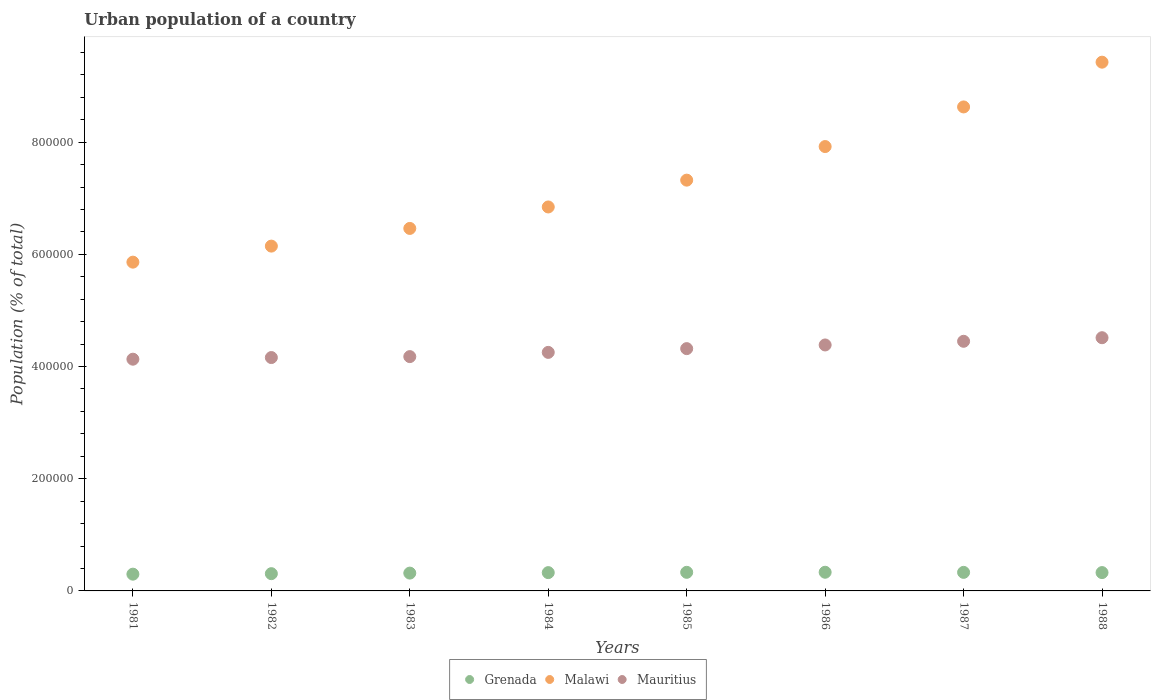How many different coloured dotlines are there?
Your answer should be very brief. 3. Is the number of dotlines equal to the number of legend labels?
Give a very brief answer. Yes. What is the urban population in Malawi in 1985?
Your response must be concise. 7.32e+05. Across all years, what is the maximum urban population in Malawi?
Offer a very short reply. 9.43e+05. Across all years, what is the minimum urban population in Mauritius?
Offer a terse response. 4.13e+05. In which year was the urban population in Malawi maximum?
Provide a succinct answer. 1988. What is the total urban population in Malawi in the graph?
Your answer should be very brief. 5.86e+06. What is the difference between the urban population in Malawi in 1984 and that in 1985?
Your answer should be very brief. -4.78e+04. What is the difference between the urban population in Mauritius in 1985 and the urban population in Malawi in 1982?
Make the answer very short. -1.83e+05. What is the average urban population in Mauritius per year?
Make the answer very short. 4.30e+05. In the year 1984, what is the difference between the urban population in Mauritius and urban population in Grenada?
Offer a very short reply. 3.93e+05. What is the ratio of the urban population in Grenada in 1982 to that in 1988?
Your answer should be very brief. 0.94. Is the difference between the urban population in Mauritius in 1986 and 1987 greater than the difference between the urban population in Grenada in 1986 and 1987?
Make the answer very short. No. What is the difference between the highest and the second highest urban population in Malawi?
Provide a succinct answer. 7.98e+04. What is the difference between the highest and the lowest urban population in Mauritius?
Give a very brief answer. 3.83e+04. Does the urban population in Grenada monotonically increase over the years?
Give a very brief answer. No. Is the urban population in Mauritius strictly less than the urban population in Grenada over the years?
Your response must be concise. No. How many dotlines are there?
Give a very brief answer. 3. How many years are there in the graph?
Provide a succinct answer. 8. What is the difference between two consecutive major ticks on the Y-axis?
Offer a terse response. 2.00e+05. Are the values on the major ticks of Y-axis written in scientific E-notation?
Provide a short and direct response. No. Does the graph contain any zero values?
Make the answer very short. No. Does the graph contain grids?
Your answer should be very brief. No. What is the title of the graph?
Your answer should be compact. Urban population of a country. What is the label or title of the Y-axis?
Your answer should be very brief. Population (% of total). What is the Population (% of total) in Grenada in 1981?
Provide a succinct answer. 2.99e+04. What is the Population (% of total) in Malawi in 1981?
Ensure brevity in your answer.  5.86e+05. What is the Population (% of total) of Mauritius in 1981?
Ensure brevity in your answer.  4.13e+05. What is the Population (% of total) of Grenada in 1982?
Your answer should be very brief. 3.08e+04. What is the Population (% of total) in Malawi in 1982?
Ensure brevity in your answer.  6.15e+05. What is the Population (% of total) in Mauritius in 1982?
Ensure brevity in your answer.  4.16e+05. What is the Population (% of total) in Grenada in 1983?
Provide a succinct answer. 3.18e+04. What is the Population (% of total) in Malawi in 1983?
Offer a terse response. 6.46e+05. What is the Population (% of total) of Mauritius in 1983?
Give a very brief answer. 4.18e+05. What is the Population (% of total) of Grenada in 1984?
Provide a short and direct response. 3.26e+04. What is the Population (% of total) of Malawi in 1984?
Your answer should be very brief. 6.84e+05. What is the Population (% of total) in Mauritius in 1984?
Give a very brief answer. 4.25e+05. What is the Population (% of total) in Grenada in 1985?
Your answer should be compact. 3.32e+04. What is the Population (% of total) in Malawi in 1985?
Your answer should be compact. 7.32e+05. What is the Population (% of total) of Mauritius in 1985?
Your answer should be compact. 4.32e+05. What is the Population (% of total) in Grenada in 1986?
Keep it short and to the point. 3.33e+04. What is the Population (% of total) in Malawi in 1986?
Offer a terse response. 7.92e+05. What is the Population (% of total) of Mauritius in 1986?
Give a very brief answer. 4.38e+05. What is the Population (% of total) of Grenada in 1987?
Make the answer very short. 3.31e+04. What is the Population (% of total) of Malawi in 1987?
Your answer should be compact. 8.63e+05. What is the Population (% of total) in Mauritius in 1987?
Offer a very short reply. 4.45e+05. What is the Population (% of total) of Grenada in 1988?
Offer a terse response. 3.27e+04. What is the Population (% of total) of Malawi in 1988?
Offer a terse response. 9.43e+05. What is the Population (% of total) in Mauritius in 1988?
Provide a succinct answer. 4.51e+05. Across all years, what is the maximum Population (% of total) of Grenada?
Ensure brevity in your answer.  3.33e+04. Across all years, what is the maximum Population (% of total) in Malawi?
Ensure brevity in your answer.  9.43e+05. Across all years, what is the maximum Population (% of total) in Mauritius?
Provide a succinct answer. 4.51e+05. Across all years, what is the minimum Population (% of total) in Grenada?
Ensure brevity in your answer.  2.99e+04. Across all years, what is the minimum Population (% of total) in Malawi?
Your answer should be very brief. 5.86e+05. Across all years, what is the minimum Population (% of total) of Mauritius?
Give a very brief answer. 4.13e+05. What is the total Population (% of total) of Grenada in the graph?
Offer a very short reply. 2.57e+05. What is the total Population (% of total) in Malawi in the graph?
Provide a short and direct response. 5.86e+06. What is the total Population (% of total) of Mauritius in the graph?
Give a very brief answer. 3.44e+06. What is the difference between the Population (% of total) in Grenada in 1981 and that in 1982?
Provide a succinct answer. -875. What is the difference between the Population (% of total) of Malawi in 1981 and that in 1982?
Keep it short and to the point. -2.86e+04. What is the difference between the Population (% of total) in Mauritius in 1981 and that in 1982?
Make the answer very short. -2927. What is the difference between the Population (% of total) in Grenada in 1981 and that in 1983?
Keep it short and to the point. -1877. What is the difference between the Population (% of total) in Malawi in 1981 and that in 1983?
Provide a succinct answer. -6.01e+04. What is the difference between the Population (% of total) in Mauritius in 1981 and that in 1983?
Your answer should be compact. -4607. What is the difference between the Population (% of total) in Grenada in 1981 and that in 1984?
Keep it short and to the point. -2739. What is the difference between the Population (% of total) of Malawi in 1981 and that in 1984?
Ensure brevity in your answer.  -9.84e+04. What is the difference between the Population (% of total) in Mauritius in 1981 and that in 1984?
Give a very brief answer. -1.21e+04. What is the difference between the Population (% of total) of Grenada in 1981 and that in 1985?
Give a very brief answer. -3273. What is the difference between the Population (% of total) of Malawi in 1981 and that in 1985?
Offer a terse response. -1.46e+05. What is the difference between the Population (% of total) in Mauritius in 1981 and that in 1985?
Provide a succinct answer. -1.88e+04. What is the difference between the Population (% of total) in Grenada in 1981 and that in 1986?
Ensure brevity in your answer.  -3402. What is the difference between the Population (% of total) of Malawi in 1981 and that in 1986?
Provide a succinct answer. -2.06e+05. What is the difference between the Population (% of total) in Mauritius in 1981 and that in 1986?
Keep it short and to the point. -2.54e+04. What is the difference between the Population (% of total) in Grenada in 1981 and that in 1987?
Ensure brevity in your answer.  -3196. What is the difference between the Population (% of total) of Malawi in 1981 and that in 1987?
Your answer should be very brief. -2.77e+05. What is the difference between the Population (% of total) in Mauritius in 1981 and that in 1987?
Provide a short and direct response. -3.19e+04. What is the difference between the Population (% of total) of Grenada in 1981 and that in 1988?
Make the answer very short. -2805. What is the difference between the Population (% of total) of Malawi in 1981 and that in 1988?
Make the answer very short. -3.57e+05. What is the difference between the Population (% of total) of Mauritius in 1981 and that in 1988?
Provide a short and direct response. -3.83e+04. What is the difference between the Population (% of total) in Grenada in 1982 and that in 1983?
Give a very brief answer. -1002. What is the difference between the Population (% of total) in Malawi in 1982 and that in 1983?
Your answer should be very brief. -3.15e+04. What is the difference between the Population (% of total) of Mauritius in 1982 and that in 1983?
Give a very brief answer. -1680. What is the difference between the Population (% of total) in Grenada in 1982 and that in 1984?
Give a very brief answer. -1864. What is the difference between the Population (% of total) in Malawi in 1982 and that in 1984?
Offer a terse response. -6.98e+04. What is the difference between the Population (% of total) of Mauritius in 1982 and that in 1984?
Make the answer very short. -9219. What is the difference between the Population (% of total) of Grenada in 1982 and that in 1985?
Offer a very short reply. -2398. What is the difference between the Population (% of total) in Malawi in 1982 and that in 1985?
Ensure brevity in your answer.  -1.18e+05. What is the difference between the Population (% of total) in Mauritius in 1982 and that in 1985?
Provide a short and direct response. -1.59e+04. What is the difference between the Population (% of total) in Grenada in 1982 and that in 1986?
Make the answer very short. -2527. What is the difference between the Population (% of total) in Malawi in 1982 and that in 1986?
Your answer should be compact. -1.77e+05. What is the difference between the Population (% of total) of Mauritius in 1982 and that in 1986?
Make the answer very short. -2.24e+04. What is the difference between the Population (% of total) of Grenada in 1982 and that in 1987?
Your answer should be very brief. -2321. What is the difference between the Population (% of total) of Malawi in 1982 and that in 1987?
Offer a very short reply. -2.48e+05. What is the difference between the Population (% of total) of Mauritius in 1982 and that in 1987?
Give a very brief answer. -2.90e+04. What is the difference between the Population (% of total) of Grenada in 1982 and that in 1988?
Give a very brief answer. -1930. What is the difference between the Population (% of total) of Malawi in 1982 and that in 1988?
Keep it short and to the point. -3.28e+05. What is the difference between the Population (% of total) of Mauritius in 1982 and that in 1988?
Make the answer very short. -3.54e+04. What is the difference between the Population (% of total) in Grenada in 1983 and that in 1984?
Ensure brevity in your answer.  -862. What is the difference between the Population (% of total) in Malawi in 1983 and that in 1984?
Your answer should be compact. -3.83e+04. What is the difference between the Population (% of total) of Mauritius in 1983 and that in 1984?
Give a very brief answer. -7539. What is the difference between the Population (% of total) in Grenada in 1983 and that in 1985?
Your answer should be very brief. -1396. What is the difference between the Population (% of total) in Malawi in 1983 and that in 1985?
Make the answer very short. -8.61e+04. What is the difference between the Population (% of total) in Mauritius in 1983 and that in 1985?
Offer a terse response. -1.42e+04. What is the difference between the Population (% of total) in Grenada in 1983 and that in 1986?
Offer a terse response. -1525. What is the difference between the Population (% of total) of Malawi in 1983 and that in 1986?
Ensure brevity in your answer.  -1.46e+05. What is the difference between the Population (% of total) in Mauritius in 1983 and that in 1986?
Keep it short and to the point. -2.08e+04. What is the difference between the Population (% of total) of Grenada in 1983 and that in 1987?
Give a very brief answer. -1319. What is the difference between the Population (% of total) in Malawi in 1983 and that in 1987?
Your response must be concise. -2.17e+05. What is the difference between the Population (% of total) of Mauritius in 1983 and that in 1987?
Make the answer very short. -2.73e+04. What is the difference between the Population (% of total) in Grenada in 1983 and that in 1988?
Your answer should be compact. -928. What is the difference between the Population (% of total) in Malawi in 1983 and that in 1988?
Provide a short and direct response. -2.96e+05. What is the difference between the Population (% of total) of Mauritius in 1983 and that in 1988?
Your answer should be compact. -3.37e+04. What is the difference between the Population (% of total) of Grenada in 1984 and that in 1985?
Make the answer very short. -534. What is the difference between the Population (% of total) in Malawi in 1984 and that in 1985?
Your response must be concise. -4.78e+04. What is the difference between the Population (% of total) in Mauritius in 1984 and that in 1985?
Your answer should be compact. -6684. What is the difference between the Population (% of total) of Grenada in 1984 and that in 1986?
Ensure brevity in your answer.  -663. What is the difference between the Population (% of total) in Malawi in 1984 and that in 1986?
Keep it short and to the point. -1.08e+05. What is the difference between the Population (% of total) of Mauritius in 1984 and that in 1986?
Keep it short and to the point. -1.32e+04. What is the difference between the Population (% of total) in Grenada in 1984 and that in 1987?
Provide a succinct answer. -457. What is the difference between the Population (% of total) of Malawi in 1984 and that in 1987?
Make the answer very short. -1.78e+05. What is the difference between the Population (% of total) of Mauritius in 1984 and that in 1987?
Your answer should be compact. -1.98e+04. What is the difference between the Population (% of total) in Grenada in 1984 and that in 1988?
Provide a succinct answer. -66. What is the difference between the Population (% of total) of Malawi in 1984 and that in 1988?
Provide a short and direct response. -2.58e+05. What is the difference between the Population (% of total) of Mauritius in 1984 and that in 1988?
Offer a very short reply. -2.61e+04. What is the difference between the Population (% of total) in Grenada in 1985 and that in 1986?
Make the answer very short. -129. What is the difference between the Population (% of total) in Malawi in 1985 and that in 1986?
Keep it short and to the point. -5.99e+04. What is the difference between the Population (% of total) of Mauritius in 1985 and that in 1986?
Your response must be concise. -6544. What is the difference between the Population (% of total) in Malawi in 1985 and that in 1987?
Keep it short and to the point. -1.31e+05. What is the difference between the Population (% of total) of Mauritius in 1985 and that in 1987?
Ensure brevity in your answer.  -1.31e+04. What is the difference between the Population (% of total) in Grenada in 1985 and that in 1988?
Provide a short and direct response. 468. What is the difference between the Population (% of total) in Malawi in 1985 and that in 1988?
Make the answer very short. -2.10e+05. What is the difference between the Population (% of total) in Mauritius in 1985 and that in 1988?
Offer a terse response. -1.95e+04. What is the difference between the Population (% of total) in Grenada in 1986 and that in 1987?
Give a very brief answer. 206. What is the difference between the Population (% of total) in Malawi in 1986 and that in 1987?
Make the answer very short. -7.06e+04. What is the difference between the Population (% of total) in Mauritius in 1986 and that in 1987?
Provide a succinct answer. -6546. What is the difference between the Population (% of total) in Grenada in 1986 and that in 1988?
Make the answer very short. 597. What is the difference between the Population (% of total) of Malawi in 1986 and that in 1988?
Your response must be concise. -1.50e+05. What is the difference between the Population (% of total) of Mauritius in 1986 and that in 1988?
Offer a very short reply. -1.29e+04. What is the difference between the Population (% of total) in Grenada in 1987 and that in 1988?
Your response must be concise. 391. What is the difference between the Population (% of total) in Malawi in 1987 and that in 1988?
Offer a very short reply. -7.98e+04. What is the difference between the Population (% of total) in Mauritius in 1987 and that in 1988?
Provide a succinct answer. -6371. What is the difference between the Population (% of total) of Grenada in 1981 and the Population (% of total) of Malawi in 1982?
Provide a short and direct response. -5.85e+05. What is the difference between the Population (% of total) of Grenada in 1981 and the Population (% of total) of Mauritius in 1982?
Provide a succinct answer. -3.86e+05. What is the difference between the Population (% of total) of Malawi in 1981 and the Population (% of total) of Mauritius in 1982?
Give a very brief answer. 1.70e+05. What is the difference between the Population (% of total) of Grenada in 1981 and the Population (% of total) of Malawi in 1983?
Provide a succinct answer. -6.16e+05. What is the difference between the Population (% of total) in Grenada in 1981 and the Population (% of total) in Mauritius in 1983?
Provide a succinct answer. -3.88e+05. What is the difference between the Population (% of total) of Malawi in 1981 and the Population (% of total) of Mauritius in 1983?
Give a very brief answer. 1.68e+05. What is the difference between the Population (% of total) of Grenada in 1981 and the Population (% of total) of Malawi in 1984?
Offer a terse response. -6.55e+05. What is the difference between the Population (% of total) of Grenada in 1981 and the Population (% of total) of Mauritius in 1984?
Make the answer very short. -3.95e+05. What is the difference between the Population (% of total) of Malawi in 1981 and the Population (% of total) of Mauritius in 1984?
Ensure brevity in your answer.  1.61e+05. What is the difference between the Population (% of total) in Grenada in 1981 and the Population (% of total) in Malawi in 1985?
Provide a succinct answer. -7.02e+05. What is the difference between the Population (% of total) in Grenada in 1981 and the Population (% of total) in Mauritius in 1985?
Provide a short and direct response. -4.02e+05. What is the difference between the Population (% of total) of Malawi in 1981 and the Population (% of total) of Mauritius in 1985?
Provide a short and direct response. 1.54e+05. What is the difference between the Population (% of total) in Grenada in 1981 and the Population (% of total) in Malawi in 1986?
Your response must be concise. -7.62e+05. What is the difference between the Population (% of total) in Grenada in 1981 and the Population (% of total) in Mauritius in 1986?
Ensure brevity in your answer.  -4.09e+05. What is the difference between the Population (% of total) of Malawi in 1981 and the Population (% of total) of Mauritius in 1986?
Your response must be concise. 1.48e+05. What is the difference between the Population (% of total) of Grenada in 1981 and the Population (% of total) of Malawi in 1987?
Give a very brief answer. -8.33e+05. What is the difference between the Population (% of total) of Grenada in 1981 and the Population (% of total) of Mauritius in 1987?
Provide a succinct answer. -4.15e+05. What is the difference between the Population (% of total) of Malawi in 1981 and the Population (% of total) of Mauritius in 1987?
Your response must be concise. 1.41e+05. What is the difference between the Population (% of total) of Grenada in 1981 and the Population (% of total) of Malawi in 1988?
Keep it short and to the point. -9.13e+05. What is the difference between the Population (% of total) of Grenada in 1981 and the Population (% of total) of Mauritius in 1988?
Give a very brief answer. -4.22e+05. What is the difference between the Population (% of total) of Malawi in 1981 and the Population (% of total) of Mauritius in 1988?
Your response must be concise. 1.35e+05. What is the difference between the Population (% of total) in Grenada in 1982 and the Population (% of total) in Malawi in 1983?
Your answer should be very brief. -6.15e+05. What is the difference between the Population (% of total) in Grenada in 1982 and the Population (% of total) in Mauritius in 1983?
Your answer should be compact. -3.87e+05. What is the difference between the Population (% of total) of Malawi in 1982 and the Population (% of total) of Mauritius in 1983?
Your answer should be compact. 1.97e+05. What is the difference between the Population (% of total) of Grenada in 1982 and the Population (% of total) of Malawi in 1984?
Ensure brevity in your answer.  -6.54e+05. What is the difference between the Population (% of total) of Grenada in 1982 and the Population (% of total) of Mauritius in 1984?
Offer a very short reply. -3.94e+05. What is the difference between the Population (% of total) in Malawi in 1982 and the Population (% of total) in Mauritius in 1984?
Keep it short and to the point. 1.89e+05. What is the difference between the Population (% of total) in Grenada in 1982 and the Population (% of total) in Malawi in 1985?
Provide a short and direct response. -7.02e+05. What is the difference between the Population (% of total) in Grenada in 1982 and the Population (% of total) in Mauritius in 1985?
Make the answer very short. -4.01e+05. What is the difference between the Population (% of total) in Malawi in 1982 and the Population (% of total) in Mauritius in 1985?
Offer a very short reply. 1.83e+05. What is the difference between the Population (% of total) of Grenada in 1982 and the Population (% of total) of Malawi in 1986?
Your response must be concise. -7.61e+05. What is the difference between the Population (% of total) of Grenada in 1982 and the Population (% of total) of Mauritius in 1986?
Your answer should be very brief. -4.08e+05. What is the difference between the Population (% of total) of Malawi in 1982 and the Population (% of total) of Mauritius in 1986?
Make the answer very short. 1.76e+05. What is the difference between the Population (% of total) in Grenada in 1982 and the Population (% of total) in Malawi in 1987?
Ensure brevity in your answer.  -8.32e+05. What is the difference between the Population (% of total) in Grenada in 1982 and the Population (% of total) in Mauritius in 1987?
Offer a very short reply. -4.14e+05. What is the difference between the Population (% of total) of Malawi in 1982 and the Population (% of total) of Mauritius in 1987?
Provide a succinct answer. 1.70e+05. What is the difference between the Population (% of total) in Grenada in 1982 and the Population (% of total) in Malawi in 1988?
Make the answer very short. -9.12e+05. What is the difference between the Population (% of total) of Grenada in 1982 and the Population (% of total) of Mauritius in 1988?
Make the answer very short. -4.21e+05. What is the difference between the Population (% of total) of Malawi in 1982 and the Population (% of total) of Mauritius in 1988?
Offer a very short reply. 1.63e+05. What is the difference between the Population (% of total) of Grenada in 1983 and the Population (% of total) of Malawi in 1984?
Your answer should be very brief. -6.53e+05. What is the difference between the Population (% of total) of Grenada in 1983 and the Population (% of total) of Mauritius in 1984?
Your answer should be very brief. -3.93e+05. What is the difference between the Population (% of total) in Malawi in 1983 and the Population (% of total) in Mauritius in 1984?
Make the answer very short. 2.21e+05. What is the difference between the Population (% of total) in Grenada in 1983 and the Population (% of total) in Malawi in 1985?
Ensure brevity in your answer.  -7.01e+05. What is the difference between the Population (% of total) in Grenada in 1983 and the Population (% of total) in Mauritius in 1985?
Keep it short and to the point. -4.00e+05. What is the difference between the Population (% of total) of Malawi in 1983 and the Population (% of total) of Mauritius in 1985?
Your response must be concise. 2.14e+05. What is the difference between the Population (% of total) in Grenada in 1983 and the Population (% of total) in Malawi in 1986?
Make the answer very short. -7.60e+05. What is the difference between the Population (% of total) in Grenada in 1983 and the Population (% of total) in Mauritius in 1986?
Keep it short and to the point. -4.07e+05. What is the difference between the Population (% of total) of Malawi in 1983 and the Population (% of total) of Mauritius in 1986?
Your response must be concise. 2.08e+05. What is the difference between the Population (% of total) of Grenada in 1983 and the Population (% of total) of Malawi in 1987?
Give a very brief answer. -8.31e+05. What is the difference between the Population (% of total) in Grenada in 1983 and the Population (% of total) in Mauritius in 1987?
Offer a very short reply. -4.13e+05. What is the difference between the Population (% of total) of Malawi in 1983 and the Population (% of total) of Mauritius in 1987?
Make the answer very short. 2.01e+05. What is the difference between the Population (% of total) of Grenada in 1983 and the Population (% of total) of Malawi in 1988?
Your answer should be compact. -9.11e+05. What is the difference between the Population (% of total) of Grenada in 1983 and the Population (% of total) of Mauritius in 1988?
Give a very brief answer. -4.20e+05. What is the difference between the Population (% of total) in Malawi in 1983 and the Population (% of total) in Mauritius in 1988?
Make the answer very short. 1.95e+05. What is the difference between the Population (% of total) of Grenada in 1984 and the Population (% of total) of Malawi in 1985?
Keep it short and to the point. -7.00e+05. What is the difference between the Population (% of total) of Grenada in 1984 and the Population (% of total) of Mauritius in 1985?
Offer a terse response. -3.99e+05. What is the difference between the Population (% of total) in Malawi in 1984 and the Population (% of total) in Mauritius in 1985?
Your answer should be very brief. 2.53e+05. What is the difference between the Population (% of total) of Grenada in 1984 and the Population (% of total) of Malawi in 1986?
Give a very brief answer. -7.60e+05. What is the difference between the Population (% of total) in Grenada in 1984 and the Population (% of total) in Mauritius in 1986?
Provide a short and direct response. -4.06e+05. What is the difference between the Population (% of total) in Malawi in 1984 and the Population (% of total) in Mauritius in 1986?
Offer a very short reply. 2.46e+05. What is the difference between the Population (% of total) in Grenada in 1984 and the Population (% of total) in Malawi in 1987?
Make the answer very short. -8.30e+05. What is the difference between the Population (% of total) of Grenada in 1984 and the Population (% of total) of Mauritius in 1987?
Offer a terse response. -4.12e+05. What is the difference between the Population (% of total) in Malawi in 1984 and the Population (% of total) in Mauritius in 1987?
Your answer should be very brief. 2.39e+05. What is the difference between the Population (% of total) of Grenada in 1984 and the Population (% of total) of Malawi in 1988?
Provide a succinct answer. -9.10e+05. What is the difference between the Population (% of total) in Grenada in 1984 and the Population (% of total) in Mauritius in 1988?
Provide a succinct answer. -4.19e+05. What is the difference between the Population (% of total) in Malawi in 1984 and the Population (% of total) in Mauritius in 1988?
Make the answer very short. 2.33e+05. What is the difference between the Population (% of total) in Grenada in 1985 and the Population (% of total) in Malawi in 1986?
Your answer should be very brief. -7.59e+05. What is the difference between the Population (% of total) in Grenada in 1985 and the Population (% of total) in Mauritius in 1986?
Your answer should be very brief. -4.05e+05. What is the difference between the Population (% of total) in Malawi in 1985 and the Population (% of total) in Mauritius in 1986?
Provide a short and direct response. 2.94e+05. What is the difference between the Population (% of total) of Grenada in 1985 and the Population (% of total) of Malawi in 1987?
Provide a succinct answer. -8.30e+05. What is the difference between the Population (% of total) of Grenada in 1985 and the Population (% of total) of Mauritius in 1987?
Provide a short and direct response. -4.12e+05. What is the difference between the Population (% of total) of Malawi in 1985 and the Population (% of total) of Mauritius in 1987?
Your answer should be compact. 2.87e+05. What is the difference between the Population (% of total) of Grenada in 1985 and the Population (% of total) of Malawi in 1988?
Your answer should be compact. -9.09e+05. What is the difference between the Population (% of total) of Grenada in 1985 and the Population (% of total) of Mauritius in 1988?
Keep it short and to the point. -4.18e+05. What is the difference between the Population (% of total) in Malawi in 1985 and the Population (% of total) in Mauritius in 1988?
Keep it short and to the point. 2.81e+05. What is the difference between the Population (% of total) of Grenada in 1986 and the Population (% of total) of Malawi in 1987?
Give a very brief answer. -8.30e+05. What is the difference between the Population (% of total) in Grenada in 1986 and the Population (% of total) in Mauritius in 1987?
Your answer should be very brief. -4.12e+05. What is the difference between the Population (% of total) of Malawi in 1986 and the Population (% of total) of Mauritius in 1987?
Ensure brevity in your answer.  3.47e+05. What is the difference between the Population (% of total) in Grenada in 1986 and the Population (% of total) in Malawi in 1988?
Offer a terse response. -9.09e+05. What is the difference between the Population (% of total) of Grenada in 1986 and the Population (% of total) of Mauritius in 1988?
Ensure brevity in your answer.  -4.18e+05. What is the difference between the Population (% of total) of Malawi in 1986 and the Population (% of total) of Mauritius in 1988?
Provide a short and direct response. 3.41e+05. What is the difference between the Population (% of total) in Grenada in 1987 and the Population (% of total) in Malawi in 1988?
Your response must be concise. -9.10e+05. What is the difference between the Population (% of total) in Grenada in 1987 and the Population (% of total) in Mauritius in 1988?
Keep it short and to the point. -4.18e+05. What is the difference between the Population (% of total) of Malawi in 1987 and the Population (% of total) of Mauritius in 1988?
Your response must be concise. 4.11e+05. What is the average Population (% of total) of Grenada per year?
Your answer should be very brief. 3.21e+04. What is the average Population (% of total) of Malawi per year?
Provide a succinct answer. 7.33e+05. What is the average Population (% of total) in Mauritius per year?
Your answer should be compact. 4.30e+05. In the year 1981, what is the difference between the Population (% of total) of Grenada and Population (% of total) of Malawi?
Your response must be concise. -5.56e+05. In the year 1981, what is the difference between the Population (% of total) in Grenada and Population (% of total) in Mauritius?
Offer a terse response. -3.83e+05. In the year 1981, what is the difference between the Population (% of total) in Malawi and Population (% of total) in Mauritius?
Keep it short and to the point. 1.73e+05. In the year 1982, what is the difference between the Population (% of total) of Grenada and Population (% of total) of Malawi?
Your answer should be very brief. -5.84e+05. In the year 1982, what is the difference between the Population (% of total) in Grenada and Population (% of total) in Mauritius?
Provide a succinct answer. -3.85e+05. In the year 1982, what is the difference between the Population (% of total) of Malawi and Population (% of total) of Mauritius?
Provide a short and direct response. 1.99e+05. In the year 1983, what is the difference between the Population (% of total) in Grenada and Population (% of total) in Malawi?
Provide a short and direct response. -6.14e+05. In the year 1983, what is the difference between the Population (% of total) in Grenada and Population (% of total) in Mauritius?
Ensure brevity in your answer.  -3.86e+05. In the year 1983, what is the difference between the Population (% of total) in Malawi and Population (% of total) in Mauritius?
Offer a very short reply. 2.29e+05. In the year 1984, what is the difference between the Population (% of total) of Grenada and Population (% of total) of Malawi?
Give a very brief answer. -6.52e+05. In the year 1984, what is the difference between the Population (% of total) of Grenada and Population (% of total) of Mauritius?
Give a very brief answer. -3.93e+05. In the year 1984, what is the difference between the Population (% of total) in Malawi and Population (% of total) in Mauritius?
Offer a very short reply. 2.59e+05. In the year 1985, what is the difference between the Population (% of total) in Grenada and Population (% of total) in Malawi?
Your response must be concise. -6.99e+05. In the year 1985, what is the difference between the Population (% of total) of Grenada and Population (% of total) of Mauritius?
Provide a short and direct response. -3.99e+05. In the year 1985, what is the difference between the Population (% of total) of Malawi and Population (% of total) of Mauritius?
Your answer should be compact. 3.00e+05. In the year 1986, what is the difference between the Population (% of total) in Grenada and Population (% of total) in Malawi?
Your response must be concise. -7.59e+05. In the year 1986, what is the difference between the Population (% of total) in Grenada and Population (% of total) in Mauritius?
Your response must be concise. -4.05e+05. In the year 1986, what is the difference between the Population (% of total) of Malawi and Population (% of total) of Mauritius?
Give a very brief answer. 3.54e+05. In the year 1987, what is the difference between the Population (% of total) of Grenada and Population (% of total) of Malawi?
Provide a succinct answer. -8.30e+05. In the year 1987, what is the difference between the Population (% of total) of Grenada and Population (% of total) of Mauritius?
Make the answer very short. -4.12e+05. In the year 1987, what is the difference between the Population (% of total) in Malawi and Population (% of total) in Mauritius?
Provide a short and direct response. 4.18e+05. In the year 1988, what is the difference between the Population (% of total) of Grenada and Population (% of total) of Malawi?
Your answer should be compact. -9.10e+05. In the year 1988, what is the difference between the Population (% of total) in Grenada and Population (% of total) in Mauritius?
Your response must be concise. -4.19e+05. In the year 1988, what is the difference between the Population (% of total) in Malawi and Population (% of total) in Mauritius?
Ensure brevity in your answer.  4.91e+05. What is the ratio of the Population (% of total) of Grenada in 1981 to that in 1982?
Ensure brevity in your answer.  0.97. What is the ratio of the Population (% of total) in Malawi in 1981 to that in 1982?
Your answer should be compact. 0.95. What is the ratio of the Population (% of total) in Grenada in 1981 to that in 1983?
Your response must be concise. 0.94. What is the ratio of the Population (% of total) of Malawi in 1981 to that in 1983?
Provide a succinct answer. 0.91. What is the ratio of the Population (% of total) in Mauritius in 1981 to that in 1983?
Offer a terse response. 0.99. What is the ratio of the Population (% of total) in Grenada in 1981 to that in 1984?
Offer a terse response. 0.92. What is the ratio of the Population (% of total) of Malawi in 1981 to that in 1984?
Your answer should be compact. 0.86. What is the ratio of the Population (% of total) in Mauritius in 1981 to that in 1984?
Your answer should be very brief. 0.97. What is the ratio of the Population (% of total) in Grenada in 1981 to that in 1985?
Ensure brevity in your answer.  0.9. What is the ratio of the Population (% of total) of Malawi in 1981 to that in 1985?
Offer a terse response. 0.8. What is the ratio of the Population (% of total) in Mauritius in 1981 to that in 1985?
Offer a very short reply. 0.96. What is the ratio of the Population (% of total) of Grenada in 1981 to that in 1986?
Make the answer very short. 0.9. What is the ratio of the Population (% of total) of Malawi in 1981 to that in 1986?
Your response must be concise. 0.74. What is the ratio of the Population (% of total) in Mauritius in 1981 to that in 1986?
Provide a short and direct response. 0.94. What is the ratio of the Population (% of total) in Grenada in 1981 to that in 1987?
Your answer should be very brief. 0.9. What is the ratio of the Population (% of total) of Malawi in 1981 to that in 1987?
Provide a short and direct response. 0.68. What is the ratio of the Population (% of total) in Mauritius in 1981 to that in 1987?
Offer a very short reply. 0.93. What is the ratio of the Population (% of total) in Grenada in 1981 to that in 1988?
Provide a short and direct response. 0.91. What is the ratio of the Population (% of total) in Malawi in 1981 to that in 1988?
Give a very brief answer. 0.62. What is the ratio of the Population (% of total) in Mauritius in 1981 to that in 1988?
Provide a short and direct response. 0.92. What is the ratio of the Population (% of total) of Grenada in 1982 to that in 1983?
Your answer should be very brief. 0.97. What is the ratio of the Population (% of total) of Malawi in 1982 to that in 1983?
Your answer should be compact. 0.95. What is the ratio of the Population (% of total) in Mauritius in 1982 to that in 1983?
Provide a short and direct response. 1. What is the ratio of the Population (% of total) of Grenada in 1982 to that in 1984?
Keep it short and to the point. 0.94. What is the ratio of the Population (% of total) in Malawi in 1982 to that in 1984?
Offer a very short reply. 0.9. What is the ratio of the Population (% of total) in Mauritius in 1982 to that in 1984?
Offer a very short reply. 0.98. What is the ratio of the Population (% of total) of Grenada in 1982 to that in 1985?
Provide a succinct answer. 0.93. What is the ratio of the Population (% of total) in Malawi in 1982 to that in 1985?
Offer a very short reply. 0.84. What is the ratio of the Population (% of total) of Mauritius in 1982 to that in 1985?
Ensure brevity in your answer.  0.96. What is the ratio of the Population (% of total) in Grenada in 1982 to that in 1986?
Your answer should be very brief. 0.92. What is the ratio of the Population (% of total) in Malawi in 1982 to that in 1986?
Your answer should be compact. 0.78. What is the ratio of the Population (% of total) of Mauritius in 1982 to that in 1986?
Give a very brief answer. 0.95. What is the ratio of the Population (% of total) of Grenada in 1982 to that in 1987?
Your answer should be compact. 0.93. What is the ratio of the Population (% of total) in Malawi in 1982 to that in 1987?
Ensure brevity in your answer.  0.71. What is the ratio of the Population (% of total) in Mauritius in 1982 to that in 1987?
Give a very brief answer. 0.93. What is the ratio of the Population (% of total) in Grenada in 1982 to that in 1988?
Your answer should be compact. 0.94. What is the ratio of the Population (% of total) of Malawi in 1982 to that in 1988?
Your answer should be compact. 0.65. What is the ratio of the Population (% of total) of Mauritius in 1982 to that in 1988?
Provide a succinct answer. 0.92. What is the ratio of the Population (% of total) in Grenada in 1983 to that in 1984?
Your response must be concise. 0.97. What is the ratio of the Population (% of total) in Malawi in 1983 to that in 1984?
Make the answer very short. 0.94. What is the ratio of the Population (% of total) of Mauritius in 1983 to that in 1984?
Your answer should be compact. 0.98. What is the ratio of the Population (% of total) of Grenada in 1983 to that in 1985?
Your answer should be very brief. 0.96. What is the ratio of the Population (% of total) of Malawi in 1983 to that in 1985?
Give a very brief answer. 0.88. What is the ratio of the Population (% of total) in Mauritius in 1983 to that in 1985?
Your answer should be compact. 0.97. What is the ratio of the Population (% of total) of Grenada in 1983 to that in 1986?
Keep it short and to the point. 0.95. What is the ratio of the Population (% of total) of Malawi in 1983 to that in 1986?
Provide a short and direct response. 0.82. What is the ratio of the Population (% of total) in Mauritius in 1983 to that in 1986?
Provide a short and direct response. 0.95. What is the ratio of the Population (% of total) of Grenada in 1983 to that in 1987?
Provide a short and direct response. 0.96. What is the ratio of the Population (% of total) in Malawi in 1983 to that in 1987?
Offer a very short reply. 0.75. What is the ratio of the Population (% of total) of Mauritius in 1983 to that in 1987?
Keep it short and to the point. 0.94. What is the ratio of the Population (% of total) of Grenada in 1983 to that in 1988?
Ensure brevity in your answer.  0.97. What is the ratio of the Population (% of total) of Malawi in 1983 to that in 1988?
Your response must be concise. 0.69. What is the ratio of the Population (% of total) of Mauritius in 1983 to that in 1988?
Your response must be concise. 0.93. What is the ratio of the Population (% of total) in Grenada in 1984 to that in 1985?
Give a very brief answer. 0.98. What is the ratio of the Population (% of total) of Malawi in 1984 to that in 1985?
Provide a succinct answer. 0.93. What is the ratio of the Population (% of total) in Mauritius in 1984 to that in 1985?
Make the answer very short. 0.98. What is the ratio of the Population (% of total) in Grenada in 1984 to that in 1986?
Keep it short and to the point. 0.98. What is the ratio of the Population (% of total) in Malawi in 1984 to that in 1986?
Give a very brief answer. 0.86. What is the ratio of the Population (% of total) in Mauritius in 1984 to that in 1986?
Give a very brief answer. 0.97. What is the ratio of the Population (% of total) in Grenada in 1984 to that in 1987?
Provide a succinct answer. 0.99. What is the ratio of the Population (% of total) of Malawi in 1984 to that in 1987?
Your answer should be very brief. 0.79. What is the ratio of the Population (% of total) in Mauritius in 1984 to that in 1987?
Your answer should be very brief. 0.96. What is the ratio of the Population (% of total) in Malawi in 1984 to that in 1988?
Make the answer very short. 0.73. What is the ratio of the Population (% of total) of Mauritius in 1984 to that in 1988?
Your response must be concise. 0.94. What is the ratio of the Population (% of total) of Grenada in 1985 to that in 1986?
Your answer should be compact. 1. What is the ratio of the Population (% of total) of Malawi in 1985 to that in 1986?
Your answer should be very brief. 0.92. What is the ratio of the Population (% of total) of Mauritius in 1985 to that in 1986?
Give a very brief answer. 0.99. What is the ratio of the Population (% of total) of Malawi in 1985 to that in 1987?
Keep it short and to the point. 0.85. What is the ratio of the Population (% of total) in Mauritius in 1985 to that in 1987?
Offer a terse response. 0.97. What is the ratio of the Population (% of total) of Grenada in 1985 to that in 1988?
Ensure brevity in your answer.  1.01. What is the ratio of the Population (% of total) of Malawi in 1985 to that in 1988?
Give a very brief answer. 0.78. What is the ratio of the Population (% of total) in Mauritius in 1985 to that in 1988?
Your answer should be very brief. 0.96. What is the ratio of the Population (% of total) in Malawi in 1986 to that in 1987?
Offer a terse response. 0.92. What is the ratio of the Population (% of total) in Grenada in 1986 to that in 1988?
Your answer should be compact. 1.02. What is the ratio of the Population (% of total) in Malawi in 1986 to that in 1988?
Keep it short and to the point. 0.84. What is the ratio of the Population (% of total) of Mauritius in 1986 to that in 1988?
Your answer should be compact. 0.97. What is the ratio of the Population (% of total) in Malawi in 1987 to that in 1988?
Your response must be concise. 0.92. What is the ratio of the Population (% of total) in Mauritius in 1987 to that in 1988?
Provide a succinct answer. 0.99. What is the difference between the highest and the second highest Population (% of total) of Grenada?
Provide a succinct answer. 129. What is the difference between the highest and the second highest Population (% of total) in Malawi?
Keep it short and to the point. 7.98e+04. What is the difference between the highest and the second highest Population (% of total) of Mauritius?
Provide a short and direct response. 6371. What is the difference between the highest and the lowest Population (% of total) in Grenada?
Provide a short and direct response. 3402. What is the difference between the highest and the lowest Population (% of total) in Malawi?
Keep it short and to the point. 3.57e+05. What is the difference between the highest and the lowest Population (% of total) of Mauritius?
Ensure brevity in your answer.  3.83e+04. 